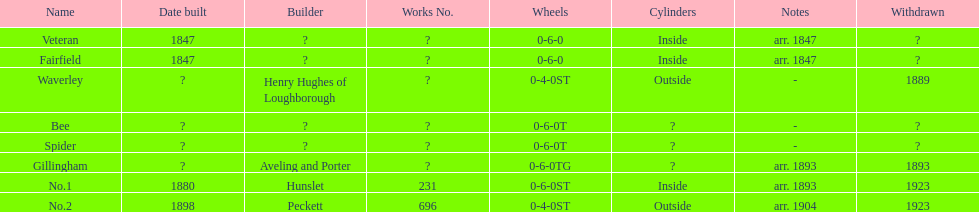Was 1847 the year when no.1 or veteran was constructed? Veteran. 